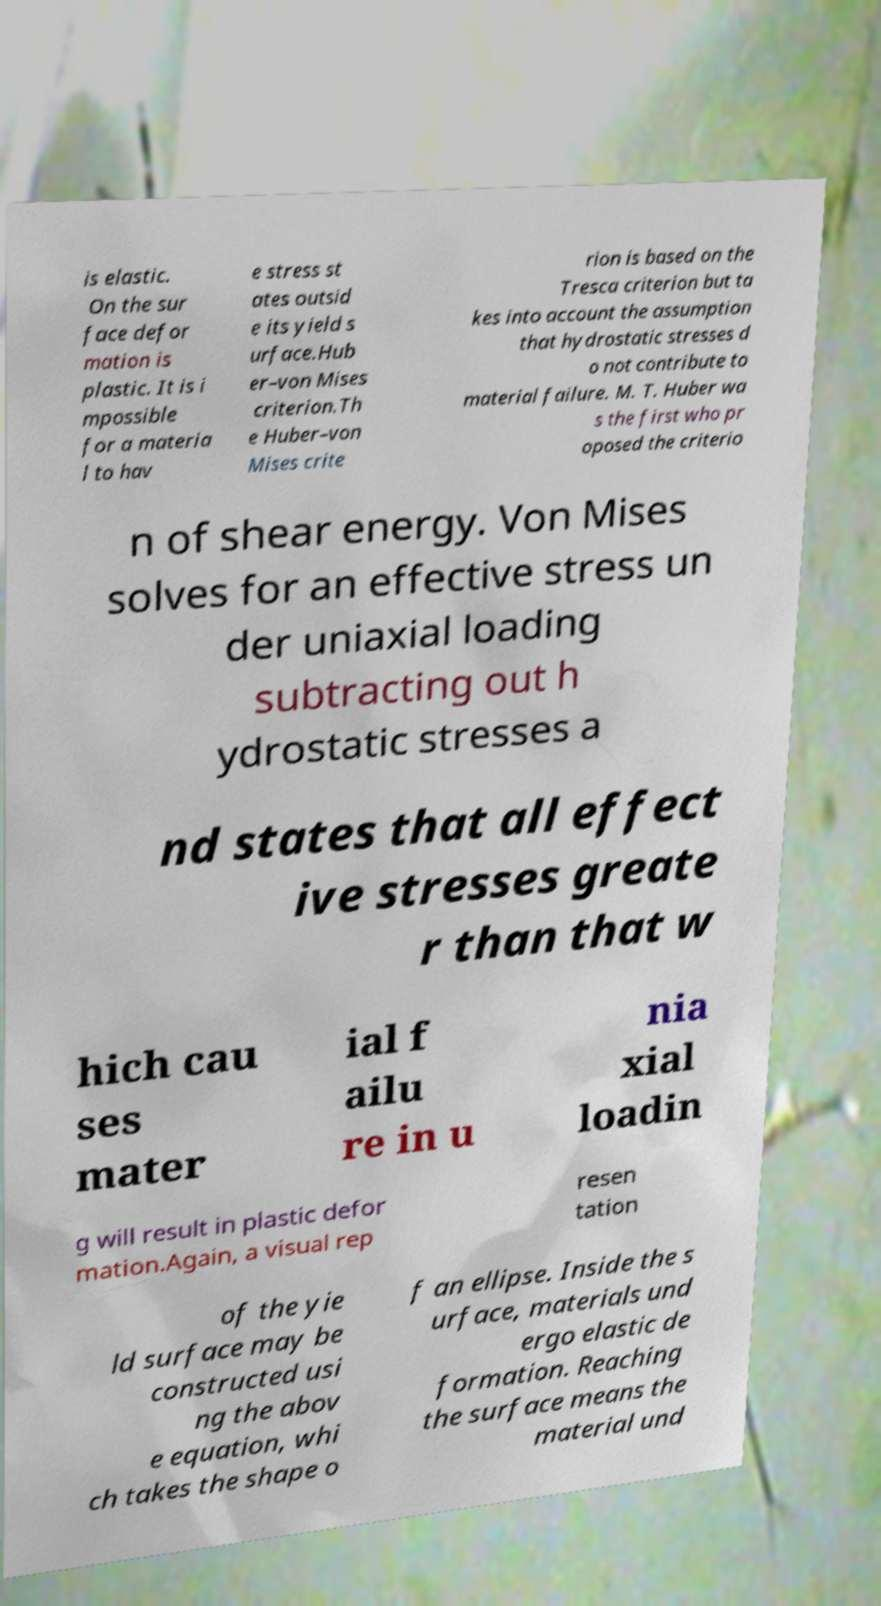I need the written content from this picture converted into text. Can you do that? is elastic. On the sur face defor mation is plastic. It is i mpossible for a materia l to hav e stress st ates outsid e its yield s urface.Hub er–von Mises criterion.Th e Huber–von Mises crite rion is based on the Tresca criterion but ta kes into account the assumption that hydrostatic stresses d o not contribute to material failure. M. T. Huber wa s the first who pr oposed the criterio n of shear energy. Von Mises solves for an effective stress un der uniaxial loading subtracting out h ydrostatic stresses a nd states that all effect ive stresses greate r than that w hich cau ses mater ial f ailu re in u nia xial loadin g will result in plastic defor mation.Again, a visual rep resen tation of the yie ld surface may be constructed usi ng the abov e equation, whi ch takes the shape o f an ellipse. Inside the s urface, materials und ergo elastic de formation. Reaching the surface means the material und 